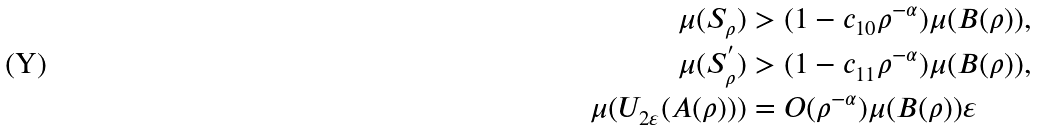Convert formula to latex. <formula><loc_0><loc_0><loc_500><loc_500>\mu ( S _ { \rho } ) & > ( 1 - c _ { 1 0 } \rho ^ { - \alpha } ) \mu ( B ( \rho ) ) , \\ \mu ( S _ { \rho } ^ { ^ { \prime } } ) & > ( 1 - c _ { 1 1 } \rho ^ { - \alpha } ) \mu ( B ( \rho ) ) , \\ \mu ( U _ { 2 \varepsilon } ( A ( \rho ) ) ) & = O ( \rho ^ { - \alpha } ) \mu ( B ( \rho ) ) \varepsilon</formula> 